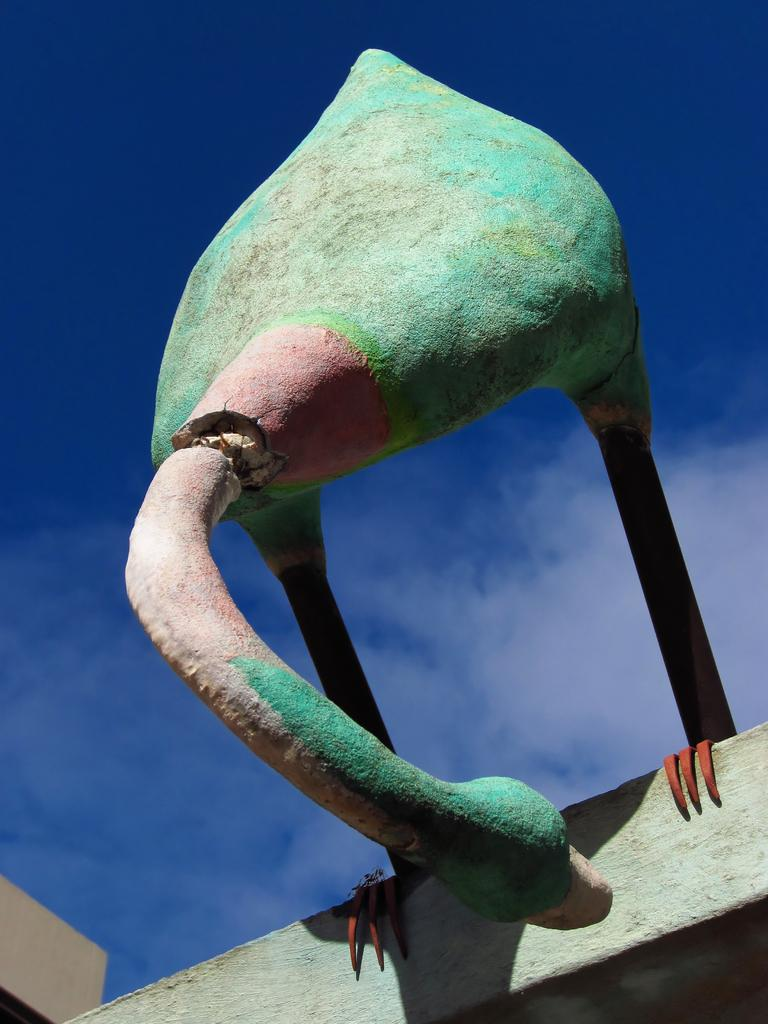What type of artwork is featured in the image? There is a sculpture of a bird in the image. What can be seen in the background of the image? The sky is visible in the image. What sound does the bell make when it is crushed in the image? There is no bell present in the image, so it cannot be crushed or make any sound. 